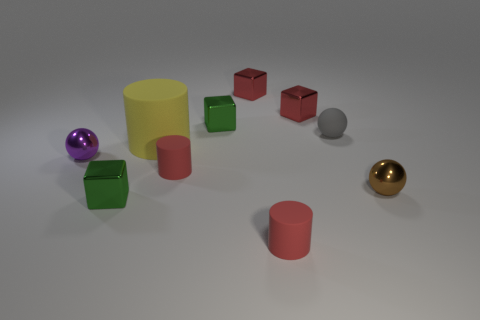If these objects were part of a child's toy set, which features might children find appealing? Children might find the bright and varied colors appealing, as well as the different geometric shapes which could be interesting to touch and stack. The shiny and matte textures would also provide a sensory experience. These features may stimulate kids' visual and tactile senses, possibly encouraging creative play and learning about shapes and colors. 